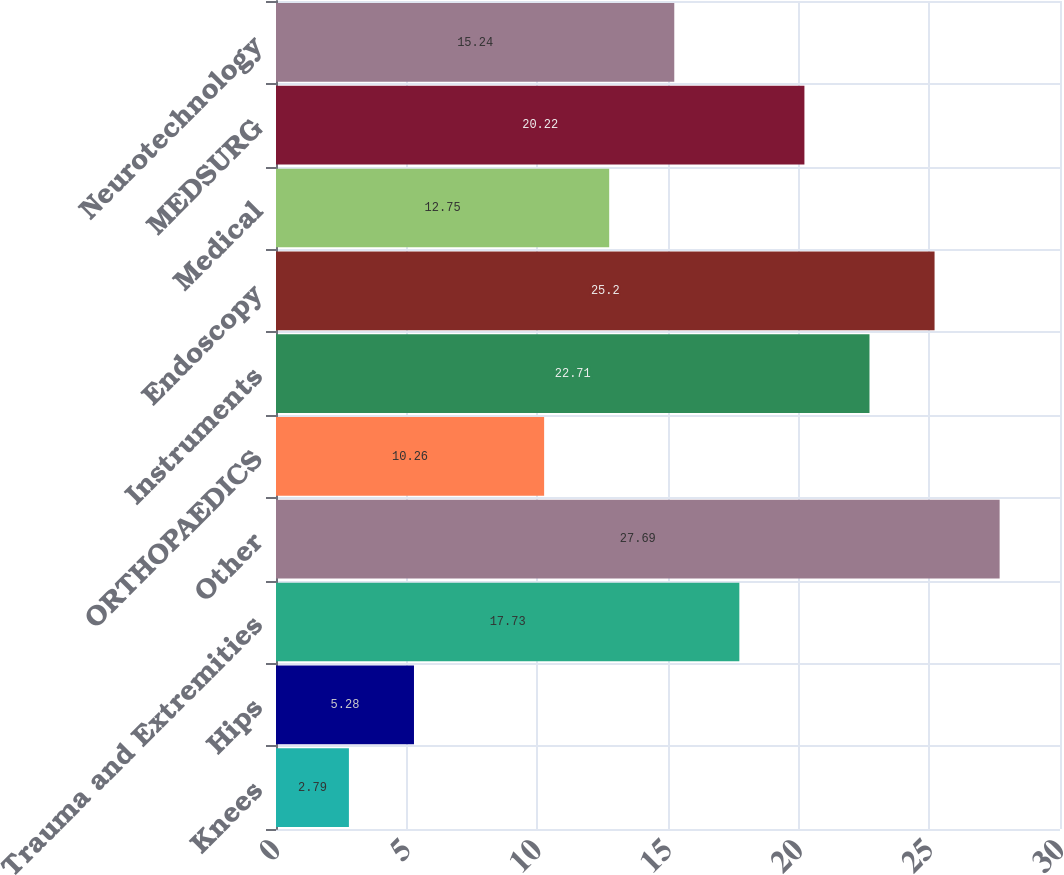Convert chart to OTSL. <chart><loc_0><loc_0><loc_500><loc_500><bar_chart><fcel>Knees<fcel>Hips<fcel>Trauma and Extremities<fcel>Other<fcel>ORTHOPAEDICS<fcel>Instruments<fcel>Endoscopy<fcel>Medical<fcel>MEDSURG<fcel>Neurotechnology<nl><fcel>2.79<fcel>5.28<fcel>17.73<fcel>27.69<fcel>10.26<fcel>22.71<fcel>25.2<fcel>12.75<fcel>20.22<fcel>15.24<nl></chart> 